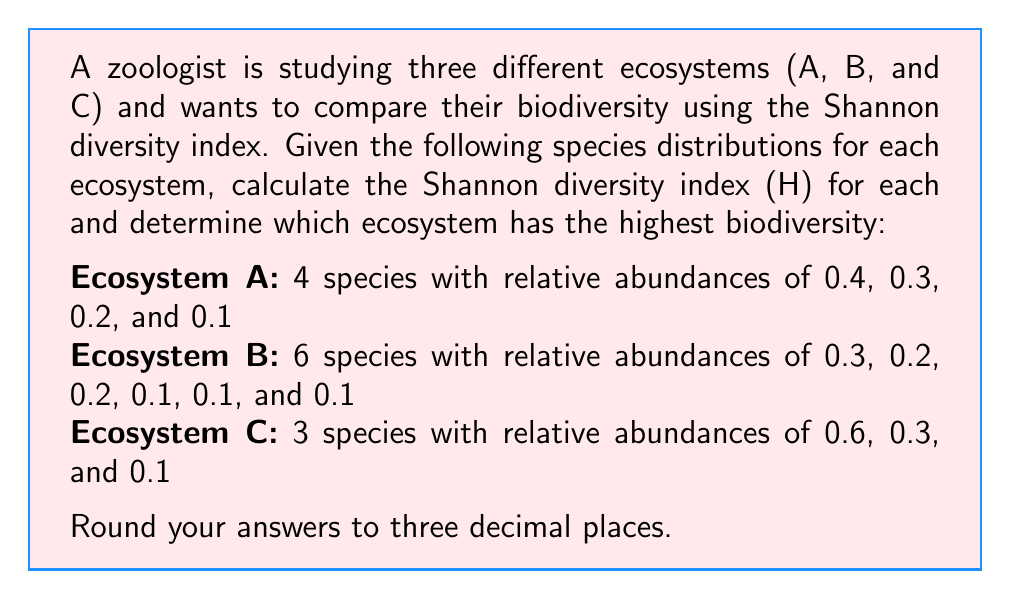Could you help me with this problem? The Shannon diversity index (H) is calculated using the formula:

$$ H = -\sum_{i=1}^{R} p_i \ln(p_i) $$

where $R$ is the number of species, and $p_i$ is the relative abundance of species $i$.

Let's calculate H for each ecosystem:

Ecosystem A:
$$ H_A = -[0.4 \ln(0.4) + 0.3 \ln(0.3) + 0.2 \ln(0.2) + 0.1 \ln(0.1)] $$
$$ H_A = -[-0.36651 - 0.36119 - 0.32189 - 0.23026] $$
$$ H_A = 1.27985 \approx 1.280 $$

Ecosystem B:
$$ H_B = -[0.3 \ln(0.3) + 0.2 \ln(0.2) + 0.2 \ln(0.2) + 0.1 \ln(0.1) + 0.1 \ln(0.1) + 0.1 \ln(0.1)] $$
$$ H_B = -[-0.36119 - 0.32189 - 0.32189 - 0.23026 - 0.23026 - 0.23026] $$
$$ H_B = 1.69575 \approx 1.696 $$

Ecosystem C:
$$ H_C = -[0.6 \ln(0.6) + 0.3 \ln(0.3) + 0.1 \ln(0.1)] $$
$$ H_C = -[-0.30650 - 0.36119 - 0.23026] $$
$$ H_C = 0.89795 \approx 0.898 $$

Comparing the results, we can see that Ecosystem B has the highest Shannon diversity index, indicating the highest biodiversity among the three ecosystems.
Answer: H_A = 1.280, H_B = 1.696, H_C = 0.898; Ecosystem B has the highest biodiversity. 